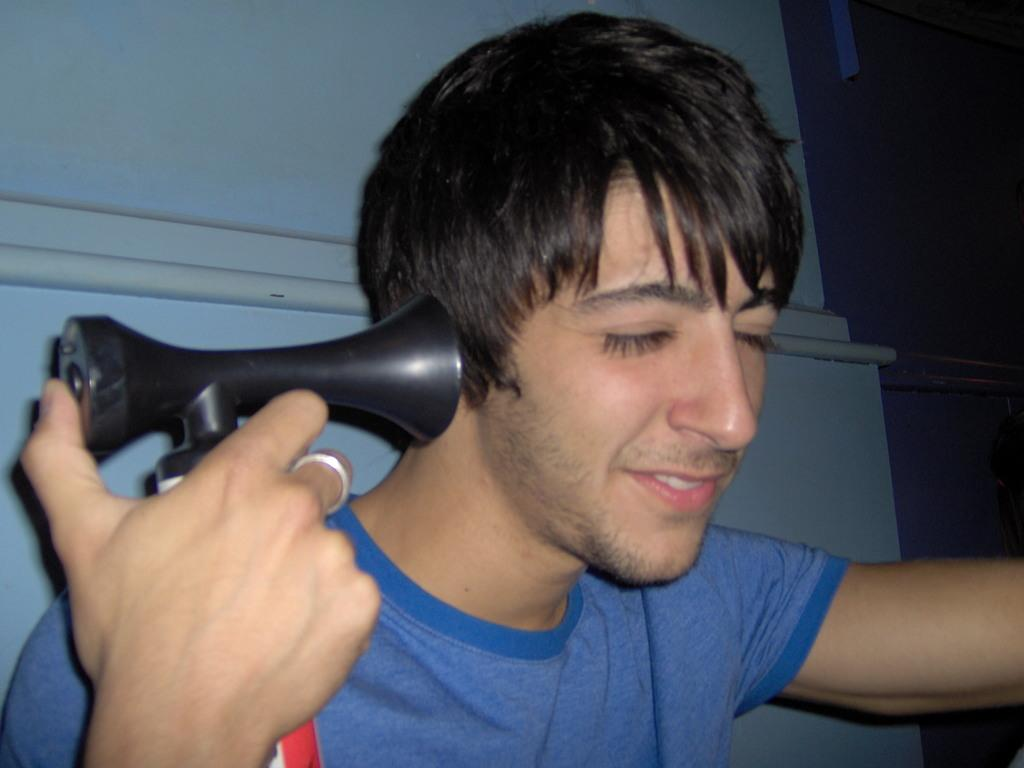Who is the main subject in the image? There is a man in the image. What is the man wearing? The man is wearing a blue t-shirt. What object is the man holding in his hand? The man is holding a hair horn in his hand. What can be seen in the background of the image? There is a wall in the background of the image. What type of gun is the man using in the image? There is no gun present in the image; the man is holding a hair horn. What type of office furniture can be seen in the image? There is no office furniture present in the image; it features a man holding a hair horn in front of a wall. 